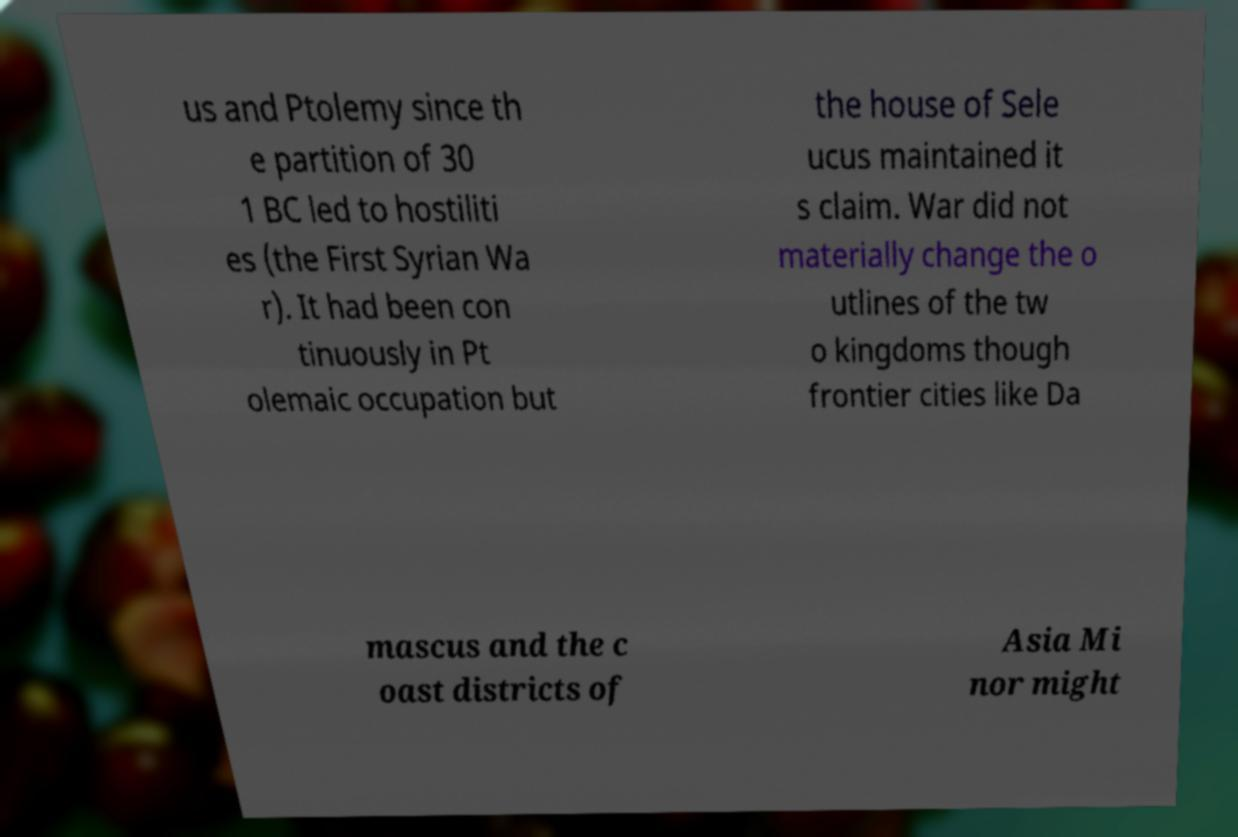Please read and relay the text visible in this image. What does it say? us and Ptolemy since th e partition of 30 1 BC led to hostiliti es (the First Syrian Wa r). It had been con tinuously in Pt olemaic occupation but the house of Sele ucus maintained it s claim. War did not materially change the o utlines of the tw o kingdoms though frontier cities like Da mascus and the c oast districts of Asia Mi nor might 